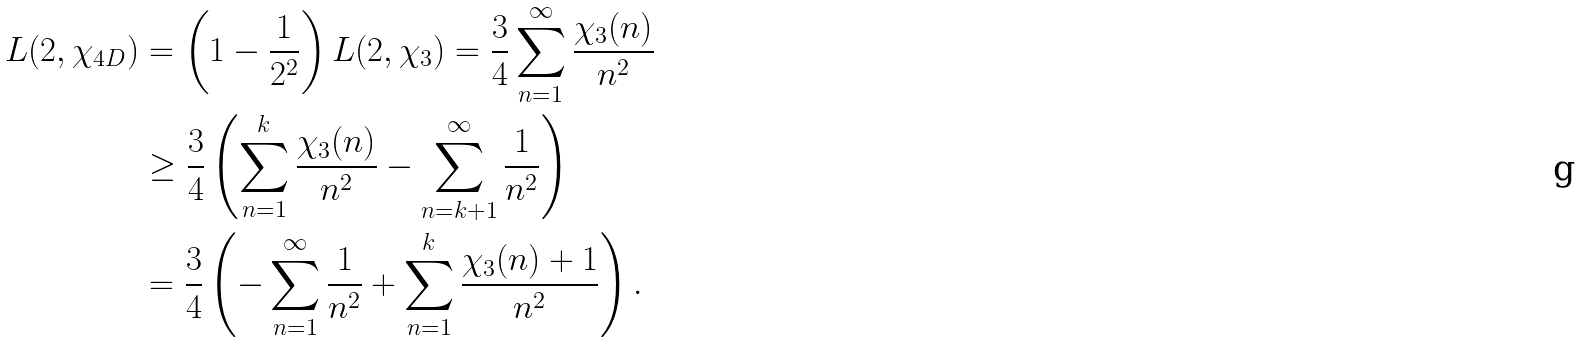<formula> <loc_0><loc_0><loc_500><loc_500>L ( 2 , \chi _ { 4 D } ) & = \left ( 1 - \frac { 1 } { 2 ^ { 2 } } \right ) L ( 2 , \chi _ { 3 } ) = \frac { 3 } { 4 } \sum _ { n = 1 } ^ { \infty } \frac { \chi _ { 3 } ( n ) } { n ^ { 2 } } \\ & \geq \frac { 3 } { 4 } \left ( \sum _ { n = 1 } ^ { k } \frac { \chi _ { 3 } ( n ) } { n ^ { 2 } } - \sum _ { n = k + 1 } ^ { \infty } \frac { 1 } { n ^ { 2 } } \right ) \\ & = \frac { 3 } { 4 } \left ( - \sum _ { n = 1 } ^ { \infty } \frac { 1 } { n ^ { 2 } } + \sum _ { n = 1 } ^ { k } \frac { \chi _ { 3 } ( n ) + 1 } { n ^ { 2 } } \right ) .</formula> 